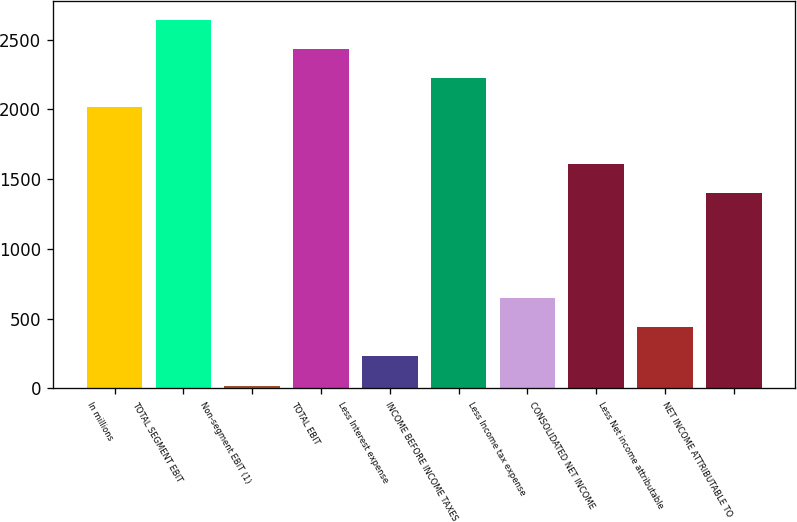Convert chart. <chart><loc_0><loc_0><loc_500><loc_500><bar_chart><fcel>In millions<fcel>TOTAL SEGMENT EBIT<fcel>Non-segment EBIT (1)<fcel>TOTAL EBIT<fcel>Less Interest expense<fcel>INCOME BEFORE INCOME TAXES<fcel>Less Income tax expense<fcel>CONSOLIDATED NET INCOME<fcel>Less Net income attributable<fcel>NET INCOME ATTRIBUTABLE TO<nl><fcel>2015<fcel>2642<fcel>20<fcel>2433<fcel>229<fcel>2224<fcel>647<fcel>1608<fcel>438<fcel>1399<nl></chart> 